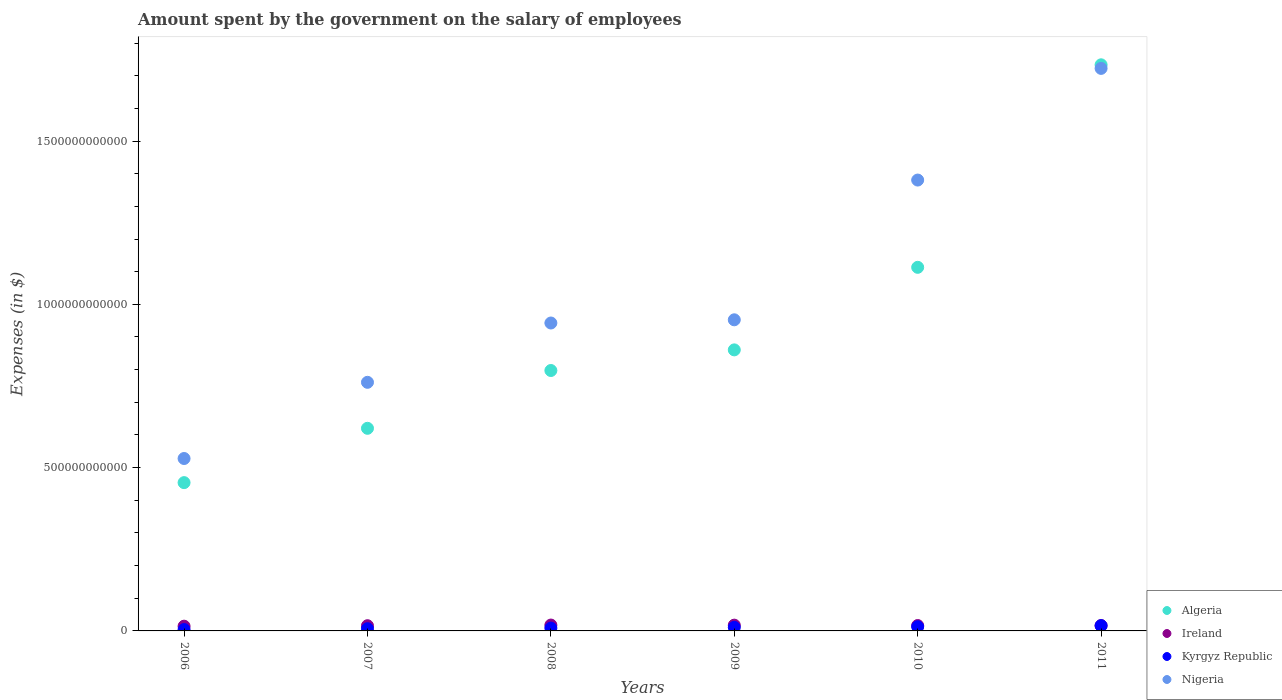What is the amount spent on the salary of employees by the government in Nigeria in 2006?
Provide a short and direct response. 5.28e+11. Across all years, what is the maximum amount spent on the salary of employees by the government in Algeria?
Provide a short and direct response. 1.73e+12. Across all years, what is the minimum amount spent on the salary of employees by the government in Algeria?
Your response must be concise. 4.54e+11. In which year was the amount spent on the salary of employees by the government in Algeria maximum?
Your response must be concise. 2011. In which year was the amount spent on the salary of employees by the government in Kyrgyz Republic minimum?
Provide a succinct answer. 2006. What is the total amount spent on the salary of employees by the government in Ireland in the graph?
Your answer should be compact. 9.89e+1. What is the difference between the amount spent on the salary of employees by the government in Algeria in 2009 and that in 2010?
Ensure brevity in your answer.  -2.53e+11. What is the difference between the amount spent on the salary of employees by the government in Kyrgyz Republic in 2006 and the amount spent on the salary of employees by the government in Ireland in 2010?
Provide a succinct answer. -1.23e+1. What is the average amount spent on the salary of employees by the government in Ireland per year?
Offer a very short reply. 1.65e+1. In the year 2009, what is the difference between the amount spent on the salary of employees by the government in Algeria and amount spent on the salary of employees by the government in Nigeria?
Offer a very short reply. -9.21e+1. In how many years, is the amount spent on the salary of employees by the government in Kyrgyz Republic greater than 1100000000000 $?
Offer a very short reply. 0. What is the ratio of the amount spent on the salary of employees by the government in Ireland in 2008 to that in 2009?
Provide a short and direct response. 1.02. What is the difference between the highest and the second highest amount spent on the salary of employees by the government in Ireland?
Your answer should be compact. 2.99e+08. What is the difference between the highest and the lowest amount spent on the salary of employees by the government in Nigeria?
Give a very brief answer. 1.19e+12. Does the amount spent on the salary of employees by the government in Kyrgyz Republic monotonically increase over the years?
Make the answer very short. Yes. Is the amount spent on the salary of employees by the government in Algeria strictly greater than the amount spent on the salary of employees by the government in Ireland over the years?
Offer a terse response. Yes. Is the amount spent on the salary of employees by the government in Nigeria strictly less than the amount spent on the salary of employees by the government in Algeria over the years?
Offer a very short reply. No. How many dotlines are there?
Your answer should be compact. 4. How many years are there in the graph?
Offer a terse response. 6. What is the difference between two consecutive major ticks on the Y-axis?
Your answer should be compact. 5.00e+11. Are the values on the major ticks of Y-axis written in scientific E-notation?
Your response must be concise. No. Does the graph contain any zero values?
Your answer should be compact. No. What is the title of the graph?
Provide a succinct answer. Amount spent by the government on the salary of employees. What is the label or title of the Y-axis?
Ensure brevity in your answer.  Expenses (in $). What is the Expenses (in $) of Algeria in 2006?
Give a very brief answer. 4.54e+11. What is the Expenses (in $) of Ireland in 2006?
Your response must be concise. 1.45e+1. What is the Expenses (in $) in Kyrgyz Republic in 2006?
Provide a succinct answer. 4.17e+09. What is the Expenses (in $) of Nigeria in 2006?
Provide a short and direct response. 5.28e+11. What is the Expenses (in $) in Algeria in 2007?
Make the answer very short. 6.20e+11. What is the Expenses (in $) in Ireland in 2007?
Make the answer very short. 1.59e+1. What is the Expenses (in $) of Kyrgyz Republic in 2007?
Your answer should be compact. 6.85e+09. What is the Expenses (in $) in Nigeria in 2007?
Provide a succinct answer. 7.61e+11. What is the Expenses (in $) of Algeria in 2008?
Provide a succinct answer. 7.97e+11. What is the Expenses (in $) of Ireland in 2008?
Keep it short and to the point. 1.80e+1. What is the Expenses (in $) in Kyrgyz Republic in 2008?
Ensure brevity in your answer.  8.69e+09. What is the Expenses (in $) in Nigeria in 2008?
Provide a succinct answer. 9.43e+11. What is the Expenses (in $) of Algeria in 2009?
Your answer should be very brief. 8.61e+11. What is the Expenses (in $) in Ireland in 2009?
Offer a terse response. 1.77e+1. What is the Expenses (in $) in Kyrgyz Republic in 2009?
Keep it short and to the point. 1.09e+1. What is the Expenses (in $) in Nigeria in 2009?
Offer a very short reply. 9.53e+11. What is the Expenses (in $) of Algeria in 2010?
Offer a very short reply. 1.11e+12. What is the Expenses (in $) of Ireland in 2010?
Keep it short and to the point. 1.65e+1. What is the Expenses (in $) of Kyrgyz Republic in 2010?
Your response must be concise. 1.29e+1. What is the Expenses (in $) of Nigeria in 2010?
Provide a succinct answer. 1.38e+12. What is the Expenses (in $) in Algeria in 2011?
Keep it short and to the point. 1.73e+12. What is the Expenses (in $) of Ireland in 2011?
Keep it short and to the point. 1.63e+1. What is the Expenses (in $) in Kyrgyz Republic in 2011?
Offer a terse response. 1.61e+1. What is the Expenses (in $) of Nigeria in 2011?
Keep it short and to the point. 1.72e+12. Across all years, what is the maximum Expenses (in $) of Algeria?
Offer a terse response. 1.73e+12. Across all years, what is the maximum Expenses (in $) in Ireland?
Keep it short and to the point. 1.80e+1. Across all years, what is the maximum Expenses (in $) in Kyrgyz Republic?
Keep it short and to the point. 1.61e+1. Across all years, what is the maximum Expenses (in $) in Nigeria?
Your answer should be compact. 1.72e+12. Across all years, what is the minimum Expenses (in $) of Algeria?
Provide a short and direct response. 4.54e+11. Across all years, what is the minimum Expenses (in $) of Ireland?
Offer a very short reply. 1.45e+1. Across all years, what is the minimum Expenses (in $) of Kyrgyz Republic?
Your answer should be very brief. 4.17e+09. Across all years, what is the minimum Expenses (in $) of Nigeria?
Make the answer very short. 5.28e+11. What is the total Expenses (in $) in Algeria in the graph?
Your answer should be compact. 5.58e+12. What is the total Expenses (in $) in Ireland in the graph?
Offer a very short reply. 9.89e+1. What is the total Expenses (in $) in Kyrgyz Republic in the graph?
Your response must be concise. 5.96e+1. What is the total Expenses (in $) in Nigeria in the graph?
Provide a short and direct response. 6.29e+12. What is the difference between the Expenses (in $) of Algeria in 2006 and that in 2007?
Give a very brief answer. -1.66e+11. What is the difference between the Expenses (in $) in Ireland in 2006 and that in 2007?
Offer a very short reply. -1.43e+09. What is the difference between the Expenses (in $) of Kyrgyz Republic in 2006 and that in 2007?
Keep it short and to the point. -2.67e+09. What is the difference between the Expenses (in $) of Nigeria in 2006 and that in 2007?
Provide a short and direct response. -2.33e+11. What is the difference between the Expenses (in $) in Algeria in 2006 and that in 2008?
Your response must be concise. -3.43e+11. What is the difference between the Expenses (in $) of Ireland in 2006 and that in 2008?
Provide a short and direct response. -3.45e+09. What is the difference between the Expenses (in $) in Kyrgyz Republic in 2006 and that in 2008?
Keep it short and to the point. -4.52e+09. What is the difference between the Expenses (in $) of Nigeria in 2006 and that in 2008?
Make the answer very short. -4.15e+11. What is the difference between the Expenses (in $) in Algeria in 2006 and that in 2009?
Keep it short and to the point. -4.06e+11. What is the difference between the Expenses (in $) of Ireland in 2006 and that in 2009?
Provide a short and direct response. -3.15e+09. What is the difference between the Expenses (in $) in Kyrgyz Republic in 2006 and that in 2009?
Offer a terse response. -6.76e+09. What is the difference between the Expenses (in $) of Nigeria in 2006 and that in 2009?
Keep it short and to the point. -4.25e+11. What is the difference between the Expenses (in $) of Algeria in 2006 and that in 2010?
Make the answer very short. -6.59e+11. What is the difference between the Expenses (in $) of Ireland in 2006 and that in 2010?
Provide a short and direct response. -2.00e+09. What is the difference between the Expenses (in $) of Kyrgyz Republic in 2006 and that in 2010?
Provide a succinct answer. -8.68e+09. What is the difference between the Expenses (in $) in Nigeria in 2006 and that in 2010?
Your answer should be compact. -8.53e+11. What is the difference between the Expenses (in $) of Algeria in 2006 and that in 2011?
Provide a short and direct response. -1.28e+12. What is the difference between the Expenses (in $) in Ireland in 2006 and that in 2011?
Your response must be concise. -1.82e+09. What is the difference between the Expenses (in $) in Kyrgyz Republic in 2006 and that in 2011?
Provide a short and direct response. -1.20e+1. What is the difference between the Expenses (in $) in Nigeria in 2006 and that in 2011?
Provide a succinct answer. -1.19e+12. What is the difference between the Expenses (in $) of Algeria in 2007 and that in 2008?
Provide a short and direct response. -1.77e+11. What is the difference between the Expenses (in $) in Ireland in 2007 and that in 2008?
Your answer should be compact. -2.02e+09. What is the difference between the Expenses (in $) of Kyrgyz Republic in 2007 and that in 2008?
Make the answer very short. -1.85e+09. What is the difference between the Expenses (in $) of Nigeria in 2007 and that in 2008?
Your answer should be very brief. -1.82e+11. What is the difference between the Expenses (in $) of Algeria in 2007 and that in 2009?
Provide a short and direct response. -2.40e+11. What is the difference between the Expenses (in $) of Ireland in 2007 and that in 2009?
Offer a terse response. -1.73e+09. What is the difference between the Expenses (in $) in Kyrgyz Republic in 2007 and that in 2009?
Provide a short and direct response. -4.09e+09. What is the difference between the Expenses (in $) in Nigeria in 2007 and that in 2009?
Offer a terse response. -1.91e+11. What is the difference between the Expenses (in $) in Algeria in 2007 and that in 2010?
Your response must be concise. -4.93e+11. What is the difference between the Expenses (in $) of Ireland in 2007 and that in 2010?
Offer a very short reply. -5.68e+08. What is the difference between the Expenses (in $) of Kyrgyz Republic in 2007 and that in 2010?
Offer a terse response. -6.01e+09. What is the difference between the Expenses (in $) of Nigeria in 2007 and that in 2010?
Your answer should be very brief. -6.19e+11. What is the difference between the Expenses (in $) in Algeria in 2007 and that in 2011?
Provide a short and direct response. -1.11e+12. What is the difference between the Expenses (in $) of Ireland in 2007 and that in 2011?
Your response must be concise. -3.91e+08. What is the difference between the Expenses (in $) of Kyrgyz Republic in 2007 and that in 2011?
Give a very brief answer. -9.28e+09. What is the difference between the Expenses (in $) of Nigeria in 2007 and that in 2011?
Offer a very short reply. -9.61e+11. What is the difference between the Expenses (in $) of Algeria in 2008 and that in 2009?
Keep it short and to the point. -6.32e+1. What is the difference between the Expenses (in $) in Ireland in 2008 and that in 2009?
Provide a succinct answer. 2.99e+08. What is the difference between the Expenses (in $) in Kyrgyz Republic in 2008 and that in 2009?
Offer a very short reply. -2.24e+09. What is the difference between the Expenses (in $) of Nigeria in 2008 and that in 2009?
Your answer should be very brief. -9.80e+09. What is the difference between the Expenses (in $) of Algeria in 2008 and that in 2010?
Give a very brief answer. -3.16e+11. What is the difference between the Expenses (in $) of Ireland in 2008 and that in 2010?
Your response must be concise. 1.46e+09. What is the difference between the Expenses (in $) in Kyrgyz Republic in 2008 and that in 2010?
Ensure brevity in your answer.  -4.16e+09. What is the difference between the Expenses (in $) in Nigeria in 2008 and that in 2010?
Provide a short and direct response. -4.38e+11. What is the difference between the Expenses (in $) of Algeria in 2008 and that in 2011?
Keep it short and to the point. -9.36e+11. What is the difference between the Expenses (in $) of Ireland in 2008 and that in 2011?
Keep it short and to the point. 1.63e+09. What is the difference between the Expenses (in $) of Kyrgyz Republic in 2008 and that in 2011?
Make the answer very short. -7.43e+09. What is the difference between the Expenses (in $) of Nigeria in 2008 and that in 2011?
Provide a succinct answer. -7.80e+11. What is the difference between the Expenses (in $) in Algeria in 2009 and that in 2010?
Make the answer very short. -2.53e+11. What is the difference between the Expenses (in $) in Ireland in 2009 and that in 2010?
Your response must be concise. 1.16e+09. What is the difference between the Expenses (in $) in Kyrgyz Republic in 2009 and that in 2010?
Your answer should be very brief. -1.92e+09. What is the difference between the Expenses (in $) in Nigeria in 2009 and that in 2010?
Offer a very short reply. -4.28e+11. What is the difference between the Expenses (in $) in Algeria in 2009 and that in 2011?
Your response must be concise. -8.73e+11. What is the difference between the Expenses (in $) of Ireland in 2009 and that in 2011?
Provide a succinct answer. 1.33e+09. What is the difference between the Expenses (in $) in Kyrgyz Republic in 2009 and that in 2011?
Ensure brevity in your answer.  -5.19e+09. What is the difference between the Expenses (in $) in Nigeria in 2009 and that in 2011?
Your answer should be very brief. -7.70e+11. What is the difference between the Expenses (in $) of Algeria in 2010 and that in 2011?
Provide a short and direct response. -6.20e+11. What is the difference between the Expenses (in $) in Ireland in 2010 and that in 2011?
Your answer should be very brief. 1.77e+08. What is the difference between the Expenses (in $) of Kyrgyz Republic in 2010 and that in 2011?
Ensure brevity in your answer.  -3.27e+09. What is the difference between the Expenses (in $) of Nigeria in 2010 and that in 2011?
Offer a terse response. -3.42e+11. What is the difference between the Expenses (in $) of Algeria in 2006 and the Expenses (in $) of Ireland in 2007?
Your answer should be very brief. 4.38e+11. What is the difference between the Expenses (in $) in Algeria in 2006 and the Expenses (in $) in Kyrgyz Republic in 2007?
Keep it short and to the point. 4.47e+11. What is the difference between the Expenses (in $) in Algeria in 2006 and the Expenses (in $) in Nigeria in 2007?
Provide a succinct answer. -3.07e+11. What is the difference between the Expenses (in $) of Ireland in 2006 and the Expenses (in $) of Kyrgyz Republic in 2007?
Ensure brevity in your answer.  7.66e+09. What is the difference between the Expenses (in $) of Ireland in 2006 and the Expenses (in $) of Nigeria in 2007?
Make the answer very short. -7.47e+11. What is the difference between the Expenses (in $) in Kyrgyz Republic in 2006 and the Expenses (in $) in Nigeria in 2007?
Provide a short and direct response. -7.57e+11. What is the difference between the Expenses (in $) of Algeria in 2006 and the Expenses (in $) of Ireland in 2008?
Offer a very short reply. 4.36e+11. What is the difference between the Expenses (in $) of Algeria in 2006 and the Expenses (in $) of Kyrgyz Republic in 2008?
Provide a short and direct response. 4.45e+11. What is the difference between the Expenses (in $) in Algeria in 2006 and the Expenses (in $) in Nigeria in 2008?
Provide a succinct answer. -4.89e+11. What is the difference between the Expenses (in $) in Ireland in 2006 and the Expenses (in $) in Kyrgyz Republic in 2008?
Provide a succinct answer. 5.82e+09. What is the difference between the Expenses (in $) of Ireland in 2006 and the Expenses (in $) of Nigeria in 2008?
Keep it short and to the point. -9.28e+11. What is the difference between the Expenses (in $) of Kyrgyz Republic in 2006 and the Expenses (in $) of Nigeria in 2008?
Make the answer very short. -9.39e+11. What is the difference between the Expenses (in $) in Algeria in 2006 and the Expenses (in $) in Ireland in 2009?
Ensure brevity in your answer.  4.36e+11. What is the difference between the Expenses (in $) of Algeria in 2006 and the Expenses (in $) of Kyrgyz Republic in 2009?
Offer a terse response. 4.43e+11. What is the difference between the Expenses (in $) of Algeria in 2006 and the Expenses (in $) of Nigeria in 2009?
Keep it short and to the point. -4.99e+11. What is the difference between the Expenses (in $) of Ireland in 2006 and the Expenses (in $) of Kyrgyz Republic in 2009?
Give a very brief answer. 3.58e+09. What is the difference between the Expenses (in $) of Ireland in 2006 and the Expenses (in $) of Nigeria in 2009?
Offer a very short reply. -9.38e+11. What is the difference between the Expenses (in $) in Kyrgyz Republic in 2006 and the Expenses (in $) in Nigeria in 2009?
Keep it short and to the point. -9.48e+11. What is the difference between the Expenses (in $) of Algeria in 2006 and the Expenses (in $) of Ireland in 2010?
Ensure brevity in your answer.  4.38e+11. What is the difference between the Expenses (in $) in Algeria in 2006 and the Expenses (in $) in Kyrgyz Republic in 2010?
Provide a short and direct response. 4.41e+11. What is the difference between the Expenses (in $) of Algeria in 2006 and the Expenses (in $) of Nigeria in 2010?
Offer a very short reply. -9.26e+11. What is the difference between the Expenses (in $) in Ireland in 2006 and the Expenses (in $) in Kyrgyz Republic in 2010?
Your answer should be compact. 1.65e+09. What is the difference between the Expenses (in $) of Ireland in 2006 and the Expenses (in $) of Nigeria in 2010?
Your answer should be very brief. -1.37e+12. What is the difference between the Expenses (in $) of Kyrgyz Republic in 2006 and the Expenses (in $) of Nigeria in 2010?
Keep it short and to the point. -1.38e+12. What is the difference between the Expenses (in $) of Algeria in 2006 and the Expenses (in $) of Ireland in 2011?
Give a very brief answer. 4.38e+11. What is the difference between the Expenses (in $) of Algeria in 2006 and the Expenses (in $) of Kyrgyz Republic in 2011?
Provide a short and direct response. 4.38e+11. What is the difference between the Expenses (in $) in Algeria in 2006 and the Expenses (in $) in Nigeria in 2011?
Provide a succinct answer. -1.27e+12. What is the difference between the Expenses (in $) in Ireland in 2006 and the Expenses (in $) in Kyrgyz Republic in 2011?
Offer a terse response. -1.62e+09. What is the difference between the Expenses (in $) of Ireland in 2006 and the Expenses (in $) of Nigeria in 2011?
Offer a terse response. -1.71e+12. What is the difference between the Expenses (in $) in Kyrgyz Republic in 2006 and the Expenses (in $) in Nigeria in 2011?
Provide a short and direct response. -1.72e+12. What is the difference between the Expenses (in $) in Algeria in 2007 and the Expenses (in $) in Ireland in 2008?
Your answer should be very brief. 6.02e+11. What is the difference between the Expenses (in $) in Algeria in 2007 and the Expenses (in $) in Kyrgyz Republic in 2008?
Offer a terse response. 6.12e+11. What is the difference between the Expenses (in $) of Algeria in 2007 and the Expenses (in $) of Nigeria in 2008?
Give a very brief answer. -3.22e+11. What is the difference between the Expenses (in $) in Ireland in 2007 and the Expenses (in $) in Kyrgyz Republic in 2008?
Keep it short and to the point. 7.24e+09. What is the difference between the Expenses (in $) in Ireland in 2007 and the Expenses (in $) in Nigeria in 2008?
Make the answer very short. -9.27e+11. What is the difference between the Expenses (in $) of Kyrgyz Republic in 2007 and the Expenses (in $) of Nigeria in 2008?
Provide a short and direct response. -9.36e+11. What is the difference between the Expenses (in $) in Algeria in 2007 and the Expenses (in $) in Ireland in 2009?
Keep it short and to the point. 6.03e+11. What is the difference between the Expenses (in $) of Algeria in 2007 and the Expenses (in $) of Kyrgyz Republic in 2009?
Keep it short and to the point. 6.09e+11. What is the difference between the Expenses (in $) in Algeria in 2007 and the Expenses (in $) in Nigeria in 2009?
Provide a succinct answer. -3.32e+11. What is the difference between the Expenses (in $) in Ireland in 2007 and the Expenses (in $) in Kyrgyz Republic in 2009?
Make the answer very short. 5.00e+09. What is the difference between the Expenses (in $) of Ireland in 2007 and the Expenses (in $) of Nigeria in 2009?
Your response must be concise. -9.37e+11. What is the difference between the Expenses (in $) of Kyrgyz Republic in 2007 and the Expenses (in $) of Nigeria in 2009?
Your response must be concise. -9.46e+11. What is the difference between the Expenses (in $) of Algeria in 2007 and the Expenses (in $) of Ireland in 2010?
Provide a short and direct response. 6.04e+11. What is the difference between the Expenses (in $) of Algeria in 2007 and the Expenses (in $) of Kyrgyz Republic in 2010?
Keep it short and to the point. 6.08e+11. What is the difference between the Expenses (in $) in Algeria in 2007 and the Expenses (in $) in Nigeria in 2010?
Give a very brief answer. -7.60e+11. What is the difference between the Expenses (in $) of Ireland in 2007 and the Expenses (in $) of Kyrgyz Republic in 2010?
Ensure brevity in your answer.  3.08e+09. What is the difference between the Expenses (in $) in Ireland in 2007 and the Expenses (in $) in Nigeria in 2010?
Make the answer very short. -1.36e+12. What is the difference between the Expenses (in $) of Kyrgyz Republic in 2007 and the Expenses (in $) of Nigeria in 2010?
Provide a succinct answer. -1.37e+12. What is the difference between the Expenses (in $) in Algeria in 2007 and the Expenses (in $) in Ireland in 2011?
Give a very brief answer. 6.04e+11. What is the difference between the Expenses (in $) of Algeria in 2007 and the Expenses (in $) of Kyrgyz Republic in 2011?
Offer a terse response. 6.04e+11. What is the difference between the Expenses (in $) in Algeria in 2007 and the Expenses (in $) in Nigeria in 2011?
Make the answer very short. -1.10e+12. What is the difference between the Expenses (in $) in Ireland in 2007 and the Expenses (in $) in Kyrgyz Republic in 2011?
Your answer should be compact. -1.89e+08. What is the difference between the Expenses (in $) of Ireland in 2007 and the Expenses (in $) of Nigeria in 2011?
Your answer should be compact. -1.71e+12. What is the difference between the Expenses (in $) in Kyrgyz Republic in 2007 and the Expenses (in $) in Nigeria in 2011?
Your answer should be very brief. -1.72e+12. What is the difference between the Expenses (in $) of Algeria in 2008 and the Expenses (in $) of Ireland in 2009?
Make the answer very short. 7.80e+11. What is the difference between the Expenses (in $) in Algeria in 2008 and the Expenses (in $) in Kyrgyz Republic in 2009?
Provide a short and direct response. 7.86e+11. What is the difference between the Expenses (in $) of Algeria in 2008 and the Expenses (in $) of Nigeria in 2009?
Offer a terse response. -1.55e+11. What is the difference between the Expenses (in $) in Ireland in 2008 and the Expenses (in $) in Kyrgyz Republic in 2009?
Offer a terse response. 7.03e+09. What is the difference between the Expenses (in $) of Ireland in 2008 and the Expenses (in $) of Nigeria in 2009?
Your response must be concise. -9.35e+11. What is the difference between the Expenses (in $) in Kyrgyz Republic in 2008 and the Expenses (in $) in Nigeria in 2009?
Offer a terse response. -9.44e+11. What is the difference between the Expenses (in $) of Algeria in 2008 and the Expenses (in $) of Ireland in 2010?
Your response must be concise. 7.81e+11. What is the difference between the Expenses (in $) in Algeria in 2008 and the Expenses (in $) in Kyrgyz Republic in 2010?
Give a very brief answer. 7.84e+11. What is the difference between the Expenses (in $) of Algeria in 2008 and the Expenses (in $) of Nigeria in 2010?
Keep it short and to the point. -5.83e+11. What is the difference between the Expenses (in $) in Ireland in 2008 and the Expenses (in $) in Kyrgyz Republic in 2010?
Ensure brevity in your answer.  5.11e+09. What is the difference between the Expenses (in $) in Ireland in 2008 and the Expenses (in $) in Nigeria in 2010?
Keep it short and to the point. -1.36e+12. What is the difference between the Expenses (in $) of Kyrgyz Republic in 2008 and the Expenses (in $) of Nigeria in 2010?
Provide a short and direct response. -1.37e+12. What is the difference between the Expenses (in $) of Algeria in 2008 and the Expenses (in $) of Ireland in 2011?
Your answer should be compact. 7.81e+11. What is the difference between the Expenses (in $) of Algeria in 2008 and the Expenses (in $) of Kyrgyz Republic in 2011?
Give a very brief answer. 7.81e+11. What is the difference between the Expenses (in $) in Algeria in 2008 and the Expenses (in $) in Nigeria in 2011?
Provide a short and direct response. -9.25e+11. What is the difference between the Expenses (in $) in Ireland in 2008 and the Expenses (in $) in Kyrgyz Republic in 2011?
Give a very brief answer. 1.84e+09. What is the difference between the Expenses (in $) of Ireland in 2008 and the Expenses (in $) of Nigeria in 2011?
Your response must be concise. -1.70e+12. What is the difference between the Expenses (in $) in Kyrgyz Republic in 2008 and the Expenses (in $) in Nigeria in 2011?
Your answer should be very brief. -1.71e+12. What is the difference between the Expenses (in $) in Algeria in 2009 and the Expenses (in $) in Ireland in 2010?
Offer a very short reply. 8.44e+11. What is the difference between the Expenses (in $) of Algeria in 2009 and the Expenses (in $) of Kyrgyz Republic in 2010?
Your response must be concise. 8.48e+11. What is the difference between the Expenses (in $) of Algeria in 2009 and the Expenses (in $) of Nigeria in 2010?
Give a very brief answer. -5.20e+11. What is the difference between the Expenses (in $) of Ireland in 2009 and the Expenses (in $) of Kyrgyz Republic in 2010?
Keep it short and to the point. 4.81e+09. What is the difference between the Expenses (in $) of Ireland in 2009 and the Expenses (in $) of Nigeria in 2010?
Offer a very short reply. -1.36e+12. What is the difference between the Expenses (in $) in Kyrgyz Republic in 2009 and the Expenses (in $) in Nigeria in 2010?
Ensure brevity in your answer.  -1.37e+12. What is the difference between the Expenses (in $) in Algeria in 2009 and the Expenses (in $) in Ireland in 2011?
Your answer should be compact. 8.44e+11. What is the difference between the Expenses (in $) of Algeria in 2009 and the Expenses (in $) of Kyrgyz Republic in 2011?
Give a very brief answer. 8.44e+11. What is the difference between the Expenses (in $) in Algeria in 2009 and the Expenses (in $) in Nigeria in 2011?
Give a very brief answer. -8.62e+11. What is the difference between the Expenses (in $) in Ireland in 2009 and the Expenses (in $) in Kyrgyz Republic in 2011?
Provide a succinct answer. 1.54e+09. What is the difference between the Expenses (in $) in Ireland in 2009 and the Expenses (in $) in Nigeria in 2011?
Your answer should be compact. -1.70e+12. What is the difference between the Expenses (in $) in Kyrgyz Republic in 2009 and the Expenses (in $) in Nigeria in 2011?
Keep it short and to the point. -1.71e+12. What is the difference between the Expenses (in $) of Algeria in 2010 and the Expenses (in $) of Ireland in 2011?
Keep it short and to the point. 1.10e+12. What is the difference between the Expenses (in $) in Algeria in 2010 and the Expenses (in $) in Kyrgyz Republic in 2011?
Offer a terse response. 1.10e+12. What is the difference between the Expenses (in $) of Algeria in 2010 and the Expenses (in $) of Nigeria in 2011?
Offer a terse response. -6.09e+11. What is the difference between the Expenses (in $) of Ireland in 2010 and the Expenses (in $) of Kyrgyz Republic in 2011?
Your answer should be very brief. 3.79e+08. What is the difference between the Expenses (in $) of Ireland in 2010 and the Expenses (in $) of Nigeria in 2011?
Provide a short and direct response. -1.71e+12. What is the difference between the Expenses (in $) of Kyrgyz Republic in 2010 and the Expenses (in $) of Nigeria in 2011?
Your answer should be compact. -1.71e+12. What is the average Expenses (in $) of Algeria per year?
Offer a very short reply. 9.30e+11. What is the average Expenses (in $) in Ireland per year?
Your response must be concise. 1.65e+1. What is the average Expenses (in $) of Kyrgyz Republic per year?
Provide a succinct answer. 9.94e+09. What is the average Expenses (in $) in Nigeria per year?
Keep it short and to the point. 1.05e+12. In the year 2006, what is the difference between the Expenses (in $) in Algeria and Expenses (in $) in Ireland?
Offer a terse response. 4.40e+11. In the year 2006, what is the difference between the Expenses (in $) in Algeria and Expenses (in $) in Kyrgyz Republic?
Ensure brevity in your answer.  4.50e+11. In the year 2006, what is the difference between the Expenses (in $) in Algeria and Expenses (in $) in Nigeria?
Your answer should be very brief. -7.39e+1. In the year 2006, what is the difference between the Expenses (in $) of Ireland and Expenses (in $) of Kyrgyz Republic?
Your answer should be compact. 1.03e+1. In the year 2006, what is the difference between the Expenses (in $) of Ireland and Expenses (in $) of Nigeria?
Provide a short and direct response. -5.13e+11. In the year 2006, what is the difference between the Expenses (in $) of Kyrgyz Republic and Expenses (in $) of Nigeria?
Your answer should be compact. -5.24e+11. In the year 2007, what is the difference between the Expenses (in $) of Algeria and Expenses (in $) of Ireland?
Your answer should be very brief. 6.04e+11. In the year 2007, what is the difference between the Expenses (in $) of Algeria and Expenses (in $) of Kyrgyz Republic?
Keep it short and to the point. 6.14e+11. In the year 2007, what is the difference between the Expenses (in $) of Algeria and Expenses (in $) of Nigeria?
Your answer should be very brief. -1.41e+11. In the year 2007, what is the difference between the Expenses (in $) in Ireland and Expenses (in $) in Kyrgyz Republic?
Provide a short and direct response. 9.09e+09. In the year 2007, what is the difference between the Expenses (in $) of Ireland and Expenses (in $) of Nigeria?
Offer a terse response. -7.45e+11. In the year 2007, what is the difference between the Expenses (in $) of Kyrgyz Republic and Expenses (in $) of Nigeria?
Provide a short and direct response. -7.54e+11. In the year 2008, what is the difference between the Expenses (in $) of Algeria and Expenses (in $) of Ireland?
Your answer should be very brief. 7.79e+11. In the year 2008, what is the difference between the Expenses (in $) in Algeria and Expenses (in $) in Kyrgyz Republic?
Offer a very short reply. 7.89e+11. In the year 2008, what is the difference between the Expenses (in $) in Algeria and Expenses (in $) in Nigeria?
Provide a succinct answer. -1.45e+11. In the year 2008, what is the difference between the Expenses (in $) in Ireland and Expenses (in $) in Kyrgyz Republic?
Your answer should be very brief. 9.27e+09. In the year 2008, what is the difference between the Expenses (in $) in Ireland and Expenses (in $) in Nigeria?
Ensure brevity in your answer.  -9.25e+11. In the year 2008, what is the difference between the Expenses (in $) of Kyrgyz Republic and Expenses (in $) of Nigeria?
Offer a terse response. -9.34e+11. In the year 2009, what is the difference between the Expenses (in $) of Algeria and Expenses (in $) of Ireland?
Provide a succinct answer. 8.43e+11. In the year 2009, what is the difference between the Expenses (in $) of Algeria and Expenses (in $) of Kyrgyz Republic?
Your answer should be compact. 8.50e+11. In the year 2009, what is the difference between the Expenses (in $) in Algeria and Expenses (in $) in Nigeria?
Your response must be concise. -9.21e+1. In the year 2009, what is the difference between the Expenses (in $) in Ireland and Expenses (in $) in Kyrgyz Republic?
Make the answer very short. 6.73e+09. In the year 2009, what is the difference between the Expenses (in $) in Ireland and Expenses (in $) in Nigeria?
Your response must be concise. -9.35e+11. In the year 2009, what is the difference between the Expenses (in $) of Kyrgyz Republic and Expenses (in $) of Nigeria?
Your answer should be compact. -9.42e+11. In the year 2010, what is the difference between the Expenses (in $) in Algeria and Expenses (in $) in Ireland?
Offer a terse response. 1.10e+12. In the year 2010, what is the difference between the Expenses (in $) in Algeria and Expenses (in $) in Kyrgyz Republic?
Provide a short and direct response. 1.10e+12. In the year 2010, what is the difference between the Expenses (in $) of Algeria and Expenses (in $) of Nigeria?
Make the answer very short. -2.67e+11. In the year 2010, what is the difference between the Expenses (in $) in Ireland and Expenses (in $) in Kyrgyz Republic?
Provide a short and direct response. 3.65e+09. In the year 2010, what is the difference between the Expenses (in $) of Ireland and Expenses (in $) of Nigeria?
Give a very brief answer. -1.36e+12. In the year 2010, what is the difference between the Expenses (in $) of Kyrgyz Republic and Expenses (in $) of Nigeria?
Offer a terse response. -1.37e+12. In the year 2011, what is the difference between the Expenses (in $) in Algeria and Expenses (in $) in Ireland?
Provide a short and direct response. 1.72e+12. In the year 2011, what is the difference between the Expenses (in $) of Algeria and Expenses (in $) of Kyrgyz Republic?
Your answer should be compact. 1.72e+12. In the year 2011, what is the difference between the Expenses (in $) of Algeria and Expenses (in $) of Nigeria?
Your response must be concise. 1.10e+1. In the year 2011, what is the difference between the Expenses (in $) in Ireland and Expenses (in $) in Kyrgyz Republic?
Your response must be concise. 2.03e+08. In the year 2011, what is the difference between the Expenses (in $) of Ireland and Expenses (in $) of Nigeria?
Make the answer very short. -1.71e+12. In the year 2011, what is the difference between the Expenses (in $) of Kyrgyz Republic and Expenses (in $) of Nigeria?
Provide a short and direct response. -1.71e+12. What is the ratio of the Expenses (in $) of Algeria in 2006 to that in 2007?
Your answer should be very brief. 0.73. What is the ratio of the Expenses (in $) in Ireland in 2006 to that in 2007?
Your answer should be compact. 0.91. What is the ratio of the Expenses (in $) of Kyrgyz Republic in 2006 to that in 2007?
Keep it short and to the point. 0.61. What is the ratio of the Expenses (in $) of Nigeria in 2006 to that in 2007?
Keep it short and to the point. 0.69. What is the ratio of the Expenses (in $) of Algeria in 2006 to that in 2008?
Ensure brevity in your answer.  0.57. What is the ratio of the Expenses (in $) of Ireland in 2006 to that in 2008?
Provide a succinct answer. 0.81. What is the ratio of the Expenses (in $) in Kyrgyz Republic in 2006 to that in 2008?
Your answer should be compact. 0.48. What is the ratio of the Expenses (in $) of Nigeria in 2006 to that in 2008?
Provide a short and direct response. 0.56. What is the ratio of the Expenses (in $) of Algeria in 2006 to that in 2009?
Offer a terse response. 0.53. What is the ratio of the Expenses (in $) of Ireland in 2006 to that in 2009?
Provide a short and direct response. 0.82. What is the ratio of the Expenses (in $) in Kyrgyz Republic in 2006 to that in 2009?
Your response must be concise. 0.38. What is the ratio of the Expenses (in $) in Nigeria in 2006 to that in 2009?
Provide a short and direct response. 0.55. What is the ratio of the Expenses (in $) of Algeria in 2006 to that in 2010?
Offer a terse response. 0.41. What is the ratio of the Expenses (in $) in Ireland in 2006 to that in 2010?
Your answer should be compact. 0.88. What is the ratio of the Expenses (in $) of Kyrgyz Republic in 2006 to that in 2010?
Offer a terse response. 0.32. What is the ratio of the Expenses (in $) in Nigeria in 2006 to that in 2010?
Your response must be concise. 0.38. What is the ratio of the Expenses (in $) of Algeria in 2006 to that in 2011?
Ensure brevity in your answer.  0.26. What is the ratio of the Expenses (in $) of Ireland in 2006 to that in 2011?
Your response must be concise. 0.89. What is the ratio of the Expenses (in $) in Kyrgyz Republic in 2006 to that in 2011?
Offer a very short reply. 0.26. What is the ratio of the Expenses (in $) in Nigeria in 2006 to that in 2011?
Ensure brevity in your answer.  0.31. What is the ratio of the Expenses (in $) in Algeria in 2007 to that in 2008?
Offer a very short reply. 0.78. What is the ratio of the Expenses (in $) of Ireland in 2007 to that in 2008?
Keep it short and to the point. 0.89. What is the ratio of the Expenses (in $) in Kyrgyz Republic in 2007 to that in 2008?
Keep it short and to the point. 0.79. What is the ratio of the Expenses (in $) in Nigeria in 2007 to that in 2008?
Your answer should be very brief. 0.81. What is the ratio of the Expenses (in $) in Algeria in 2007 to that in 2009?
Provide a short and direct response. 0.72. What is the ratio of the Expenses (in $) of Ireland in 2007 to that in 2009?
Keep it short and to the point. 0.9. What is the ratio of the Expenses (in $) of Kyrgyz Republic in 2007 to that in 2009?
Offer a very short reply. 0.63. What is the ratio of the Expenses (in $) of Nigeria in 2007 to that in 2009?
Provide a succinct answer. 0.8. What is the ratio of the Expenses (in $) in Algeria in 2007 to that in 2010?
Ensure brevity in your answer.  0.56. What is the ratio of the Expenses (in $) of Ireland in 2007 to that in 2010?
Provide a short and direct response. 0.97. What is the ratio of the Expenses (in $) of Kyrgyz Republic in 2007 to that in 2010?
Provide a short and direct response. 0.53. What is the ratio of the Expenses (in $) in Nigeria in 2007 to that in 2010?
Make the answer very short. 0.55. What is the ratio of the Expenses (in $) in Algeria in 2007 to that in 2011?
Give a very brief answer. 0.36. What is the ratio of the Expenses (in $) of Kyrgyz Republic in 2007 to that in 2011?
Your answer should be compact. 0.42. What is the ratio of the Expenses (in $) in Nigeria in 2007 to that in 2011?
Your response must be concise. 0.44. What is the ratio of the Expenses (in $) of Algeria in 2008 to that in 2009?
Your answer should be very brief. 0.93. What is the ratio of the Expenses (in $) of Ireland in 2008 to that in 2009?
Make the answer very short. 1.02. What is the ratio of the Expenses (in $) in Kyrgyz Republic in 2008 to that in 2009?
Ensure brevity in your answer.  0.8. What is the ratio of the Expenses (in $) of Algeria in 2008 to that in 2010?
Make the answer very short. 0.72. What is the ratio of the Expenses (in $) in Ireland in 2008 to that in 2010?
Ensure brevity in your answer.  1.09. What is the ratio of the Expenses (in $) of Kyrgyz Republic in 2008 to that in 2010?
Offer a very short reply. 0.68. What is the ratio of the Expenses (in $) in Nigeria in 2008 to that in 2010?
Your answer should be compact. 0.68. What is the ratio of the Expenses (in $) of Algeria in 2008 to that in 2011?
Your answer should be compact. 0.46. What is the ratio of the Expenses (in $) of Kyrgyz Republic in 2008 to that in 2011?
Make the answer very short. 0.54. What is the ratio of the Expenses (in $) of Nigeria in 2008 to that in 2011?
Provide a short and direct response. 0.55. What is the ratio of the Expenses (in $) of Algeria in 2009 to that in 2010?
Provide a succinct answer. 0.77. What is the ratio of the Expenses (in $) in Ireland in 2009 to that in 2010?
Your answer should be compact. 1.07. What is the ratio of the Expenses (in $) of Kyrgyz Republic in 2009 to that in 2010?
Give a very brief answer. 0.85. What is the ratio of the Expenses (in $) of Nigeria in 2009 to that in 2010?
Your answer should be very brief. 0.69. What is the ratio of the Expenses (in $) in Algeria in 2009 to that in 2011?
Your answer should be very brief. 0.5. What is the ratio of the Expenses (in $) in Ireland in 2009 to that in 2011?
Offer a terse response. 1.08. What is the ratio of the Expenses (in $) in Kyrgyz Republic in 2009 to that in 2011?
Your response must be concise. 0.68. What is the ratio of the Expenses (in $) in Nigeria in 2009 to that in 2011?
Your answer should be compact. 0.55. What is the ratio of the Expenses (in $) in Algeria in 2010 to that in 2011?
Your answer should be very brief. 0.64. What is the ratio of the Expenses (in $) in Ireland in 2010 to that in 2011?
Give a very brief answer. 1.01. What is the ratio of the Expenses (in $) in Kyrgyz Republic in 2010 to that in 2011?
Your response must be concise. 0.8. What is the ratio of the Expenses (in $) in Nigeria in 2010 to that in 2011?
Ensure brevity in your answer.  0.8. What is the difference between the highest and the second highest Expenses (in $) of Algeria?
Your response must be concise. 6.20e+11. What is the difference between the highest and the second highest Expenses (in $) in Ireland?
Your answer should be compact. 2.99e+08. What is the difference between the highest and the second highest Expenses (in $) in Kyrgyz Republic?
Keep it short and to the point. 3.27e+09. What is the difference between the highest and the second highest Expenses (in $) of Nigeria?
Keep it short and to the point. 3.42e+11. What is the difference between the highest and the lowest Expenses (in $) of Algeria?
Make the answer very short. 1.28e+12. What is the difference between the highest and the lowest Expenses (in $) of Ireland?
Offer a terse response. 3.45e+09. What is the difference between the highest and the lowest Expenses (in $) of Kyrgyz Republic?
Ensure brevity in your answer.  1.20e+1. What is the difference between the highest and the lowest Expenses (in $) of Nigeria?
Offer a terse response. 1.19e+12. 